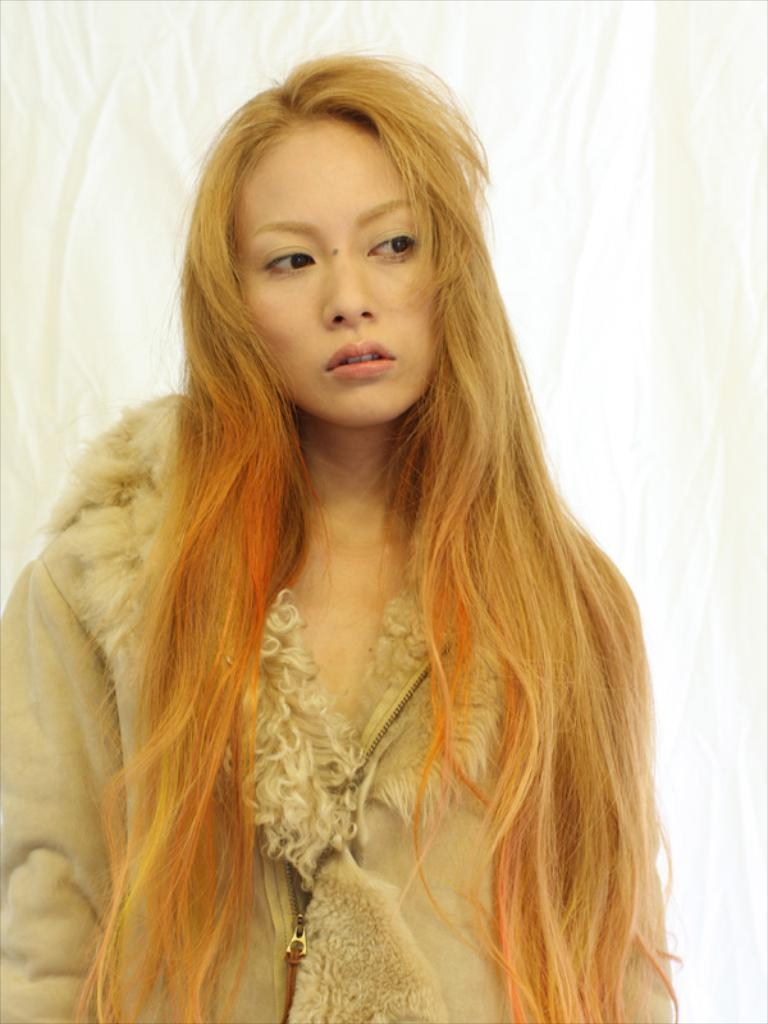Who is present in the image? There is a woman in the image. How many mice are on the canvas in the image? There is no canvas or mice present in the image; it features a woman. 